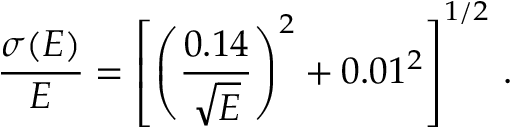<formula> <loc_0><loc_0><loc_500><loc_500>{ \frac { \sigma ( E ) } { E } } = \left [ \left ( { \frac { 0 . 1 4 } { \sqrt { E } } } \right ) ^ { 2 } + 0 . 0 1 ^ { 2 } \right ] ^ { 1 / 2 } \, .</formula> 